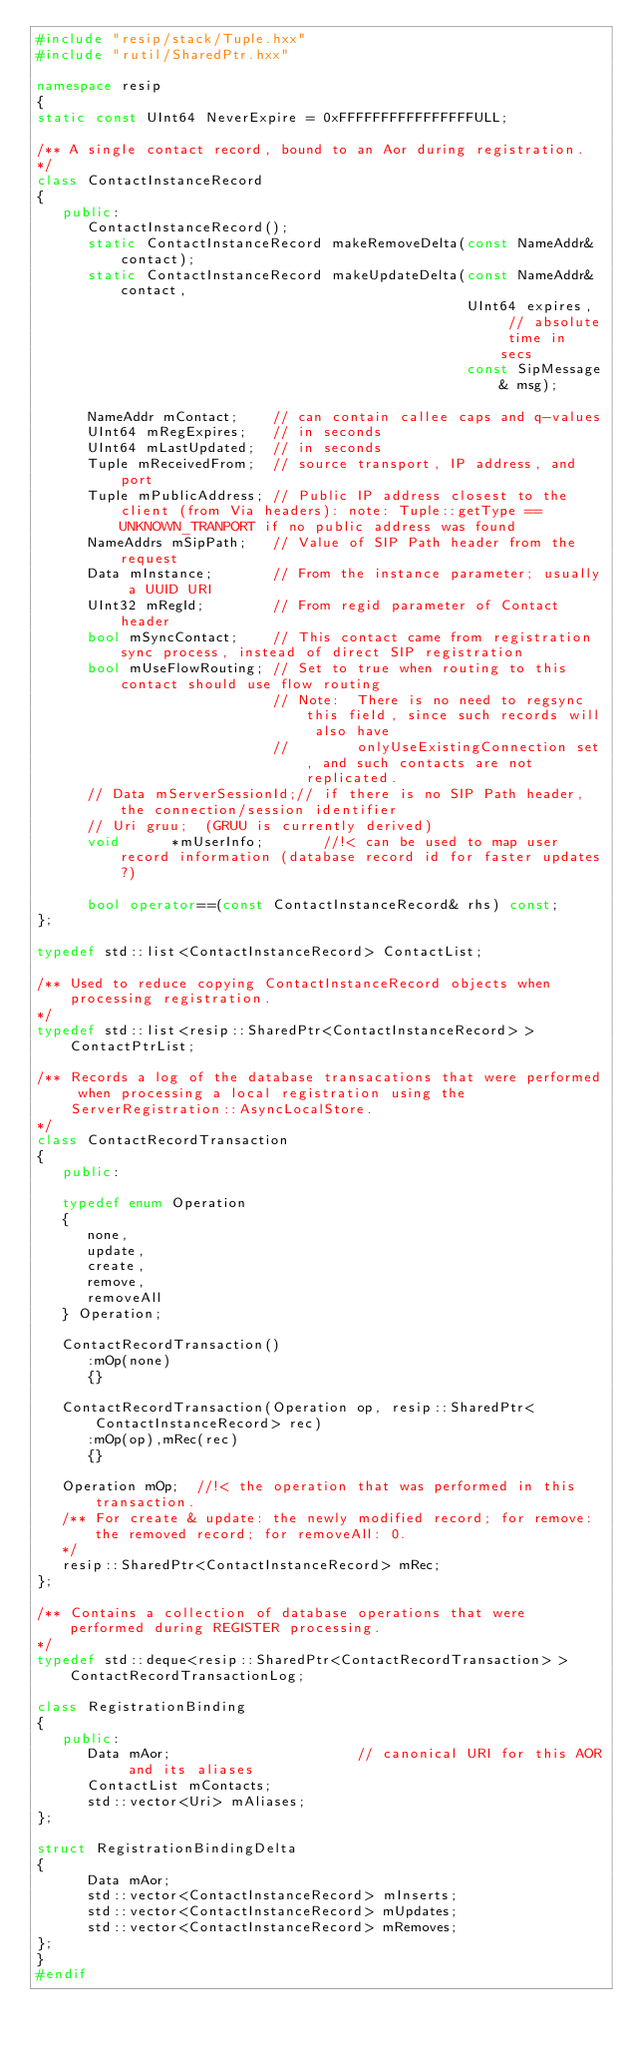<code> <loc_0><loc_0><loc_500><loc_500><_C++_>#include "resip/stack/Tuple.hxx"
#include "rutil/SharedPtr.hxx"

namespace resip
{
static const UInt64 NeverExpire = 0xFFFFFFFFFFFFFFFFULL;

/** A single contact record, bound to an Aor during registration.
*/
class ContactInstanceRecord 
{
   public:
      ContactInstanceRecord();
      static ContactInstanceRecord makeRemoveDelta(const NameAddr& contact);
      static ContactInstanceRecord makeUpdateDelta(const NameAddr& contact, 
                                                   UInt64 expires,  // absolute time in secs
                                                   const SipMessage& msg);
      
      NameAddr mContact;    // can contain callee caps and q-values
      UInt64 mRegExpires;   // in seconds
      UInt64 mLastUpdated;  // in seconds
      Tuple mReceivedFrom;  // source transport, IP address, and port
      Tuple mPublicAddress; // Public IP address closest to the client (from Via headers): note: Tuple::getType == UNKNOWN_TRANPORT if no public address was found
      NameAddrs mSipPath;   // Value of SIP Path header from the request
      Data mInstance;       // From the instance parameter; usually a UUID URI
      UInt32 mRegId;        // From regid parameter of Contact header
      bool mSyncContact;    // This contact came from registration sync process, instead of direct SIP registration
      bool mUseFlowRouting; // Set to true when routing to this contact should use flow routing 
                            // Note:  There is no need to regsync this field, since such records will also have 
                            //        onlyUseExistingConnection set, and such contacts are not replicated.
      // Data mServerSessionId;// if there is no SIP Path header, the connection/session identifier 
      // Uri gruu;  (GRUU is currently derived)
      void      *mUserInfo;       //!< can be used to map user record information (database record id for faster updates?)
      
      bool operator==(const ContactInstanceRecord& rhs) const;
};

typedef std::list<ContactInstanceRecord> ContactList;

/** Used to reduce copying ContactInstanceRecord objects when processing registration.
*/
typedef std::list<resip::SharedPtr<ContactInstanceRecord> > ContactPtrList;
	
/** Records a log of the database transacations that were performed when processing a local registration using the
    ServerRegistration::AsyncLocalStore.
*/
class ContactRecordTransaction
{
   public:

   typedef enum Operation
   {
      none,
      update,
      create,
      remove,
      removeAll
   } Operation;

   ContactRecordTransaction()
      :mOp(none)
      {}

   ContactRecordTransaction(Operation op, resip::SharedPtr<ContactInstanceRecord> rec)
      :mOp(op),mRec(rec)
      {}

   Operation mOp;  //!< the operation that was performed in this transaction.
   /** For create & update: the newly modified record; for remove: the removed record; for removeAll: 0.
   */
   resip::SharedPtr<ContactInstanceRecord> mRec;  
};

/** Contains a collection of database operations that were performed during REGISTER processing.
*/
typedef std::deque<resip::SharedPtr<ContactRecordTransaction> > ContactRecordTransactionLog;

class RegistrationBinding 
{
   public:
      Data mAor;                      // canonical URI for this AOR and its aliases
      ContactList mContacts;
      std::vector<Uri> mAliases;     
};

struct RegistrationBindingDelta
{
      Data mAor;
      std::vector<ContactInstanceRecord> mInserts;
      std::vector<ContactInstanceRecord> mUpdates;
      std::vector<ContactInstanceRecord> mRemoves;
};
}
#endif
</code> 